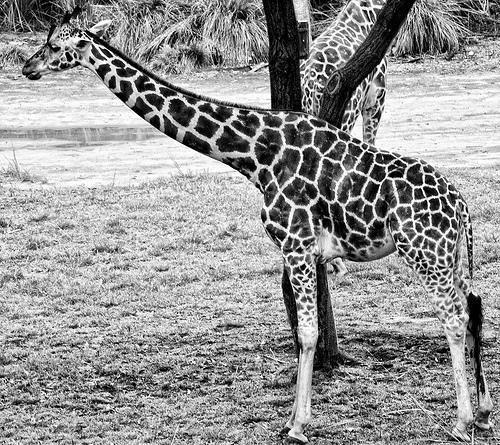How many giraffes are there?
Give a very brief answer. 2. 